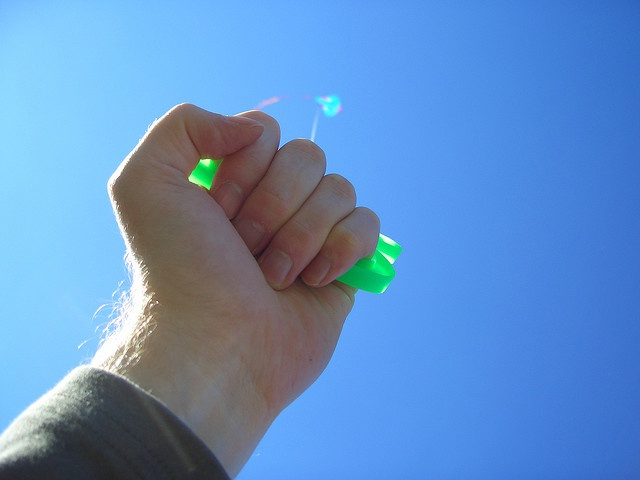Describe the objects in this image and their specific colors. I can see people in lightblue, gray, black, maroon, and white tones and kite in lightblue and cyan tones in this image. 